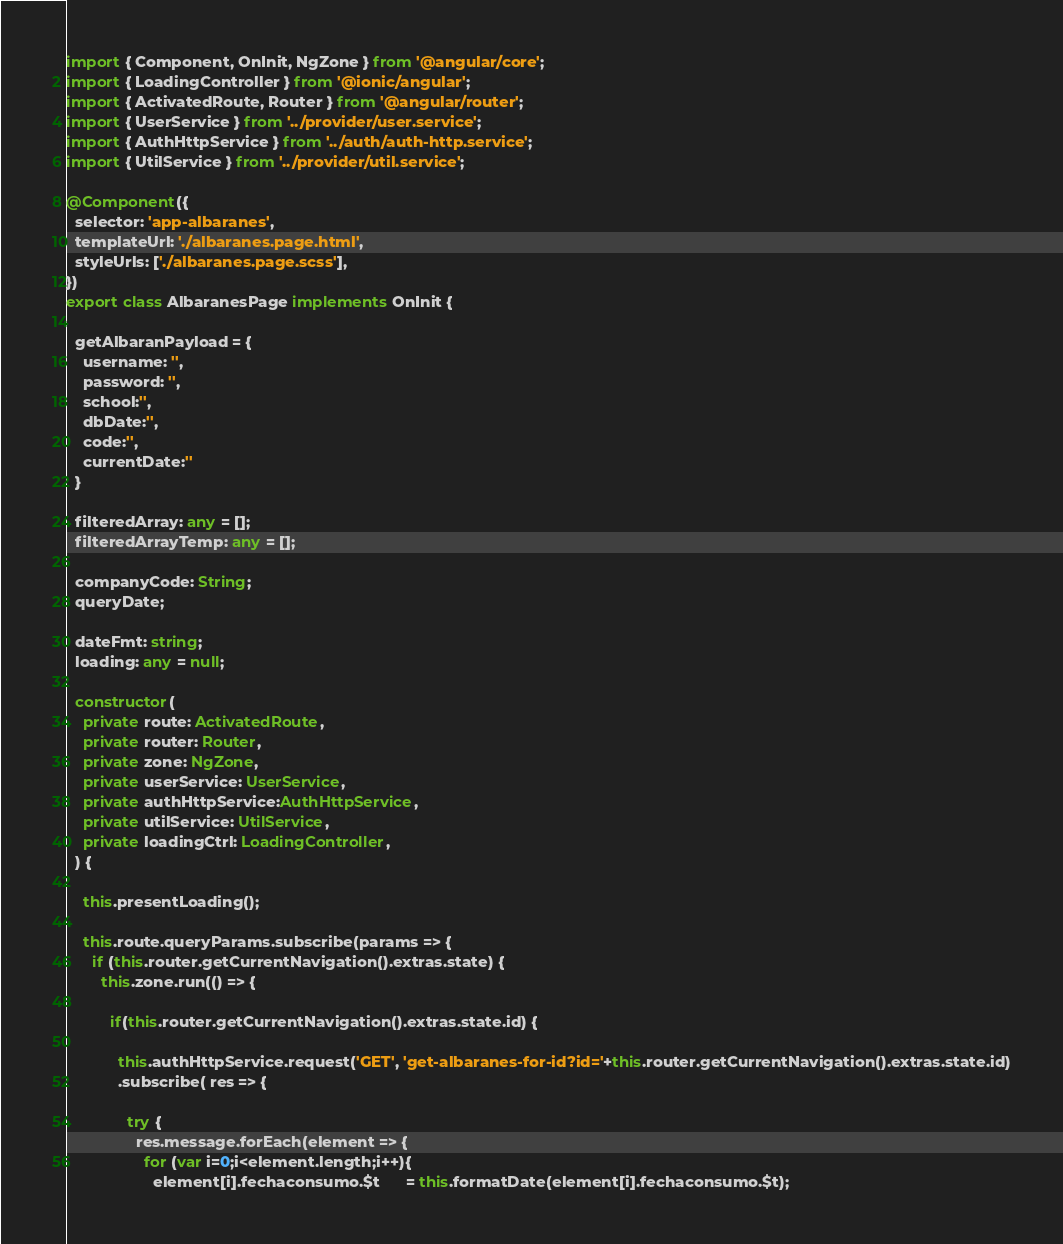Convert code to text. <code><loc_0><loc_0><loc_500><loc_500><_TypeScript_>import { Component, OnInit, NgZone } from '@angular/core';
import { LoadingController } from '@ionic/angular';
import { ActivatedRoute, Router } from '@angular/router';
import { UserService } from '../provider/user.service';
import { AuthHttpService } from '../auth/auth-http.service';
import { UtilService } from '../provider/util.service';

@Component({
  selector: 'app-albaranes',
  templateUrl: './albaranes.page.html',
  styleUrls: ['./albaranes.page.scss'],
})
export class AlbaranesPage implements OnInit {

  getAlbaranPayload = {
    username: '',
    password: '',
    school:'',
    dbDate:'',
    code:'',
    currentDate:''
  }

  filteredArray: any = [];
  filteredArrayTemp: any = [];

  companyCode: String;
  queryDate;

  dateFmt: string;
  loading: any = null;

  constructor(
    private route: ActivatedRoute,
    private router: Router,
    private zone: NgZone,
    private userService: UserService,
    private authHttpService:AuthHttpService,
    private utilService: UtilService,   
    private loadingCtrl: LoadingController,    
  ) {

    this.presentLoading();

    this.route.queryParams.subscribe(params => {
      if (this.router.getCurrentNavigation().extras.state) {
        this.zone.run(() => {

          if(this.router.getCurrentNavigation().extras.state.id) {

            this.authHttpService.request('GET', 'get-albaranes-for-id?id='+this.router.getCurrentNavigation().extras.state.id)
            .subscribe( res => {

              try {
                res.message.forEach(element => {
                  for (var i=0;i<element.length;i++){
                    element[i].fechaconsumo.$t      = this.formatDate(element[i].fechaconsumo.$t);</code> 